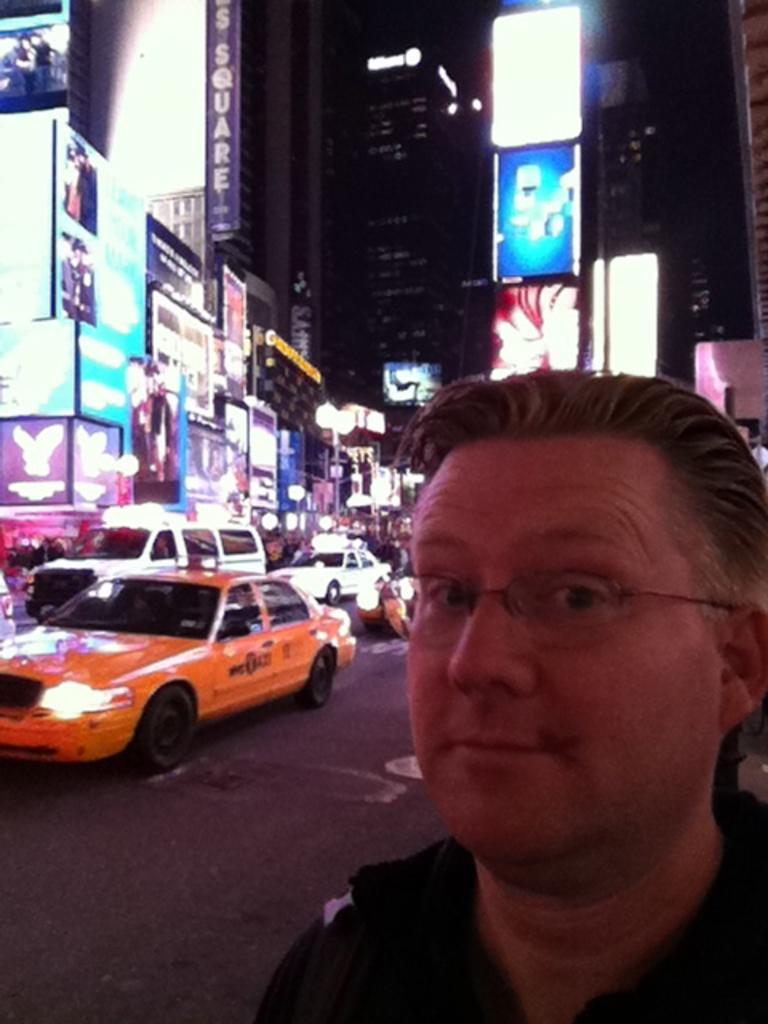Please provide a concise description of this image. In this image there is a man standing on the road behind him there are some cars and buildings. 